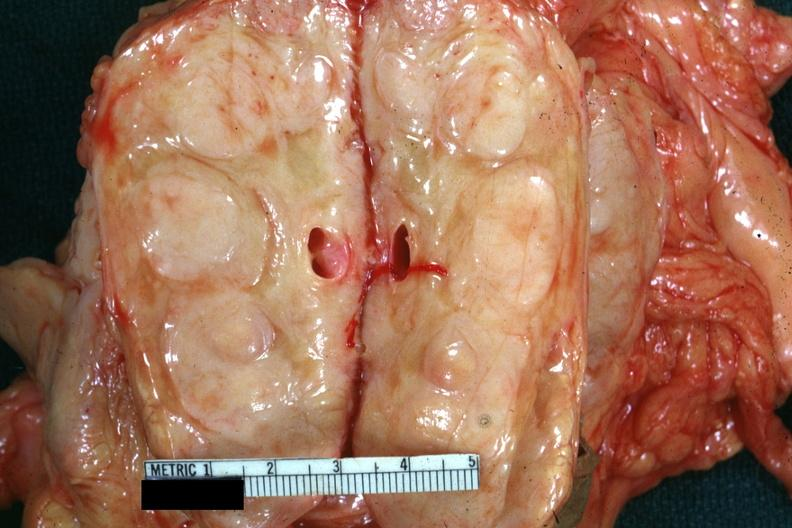what does this image show?
Answer the question using a single word or phrase. Cut edge of mesentery showing massively enlarged nodes very good example was diagnosed as reticulum cell sarcoma 